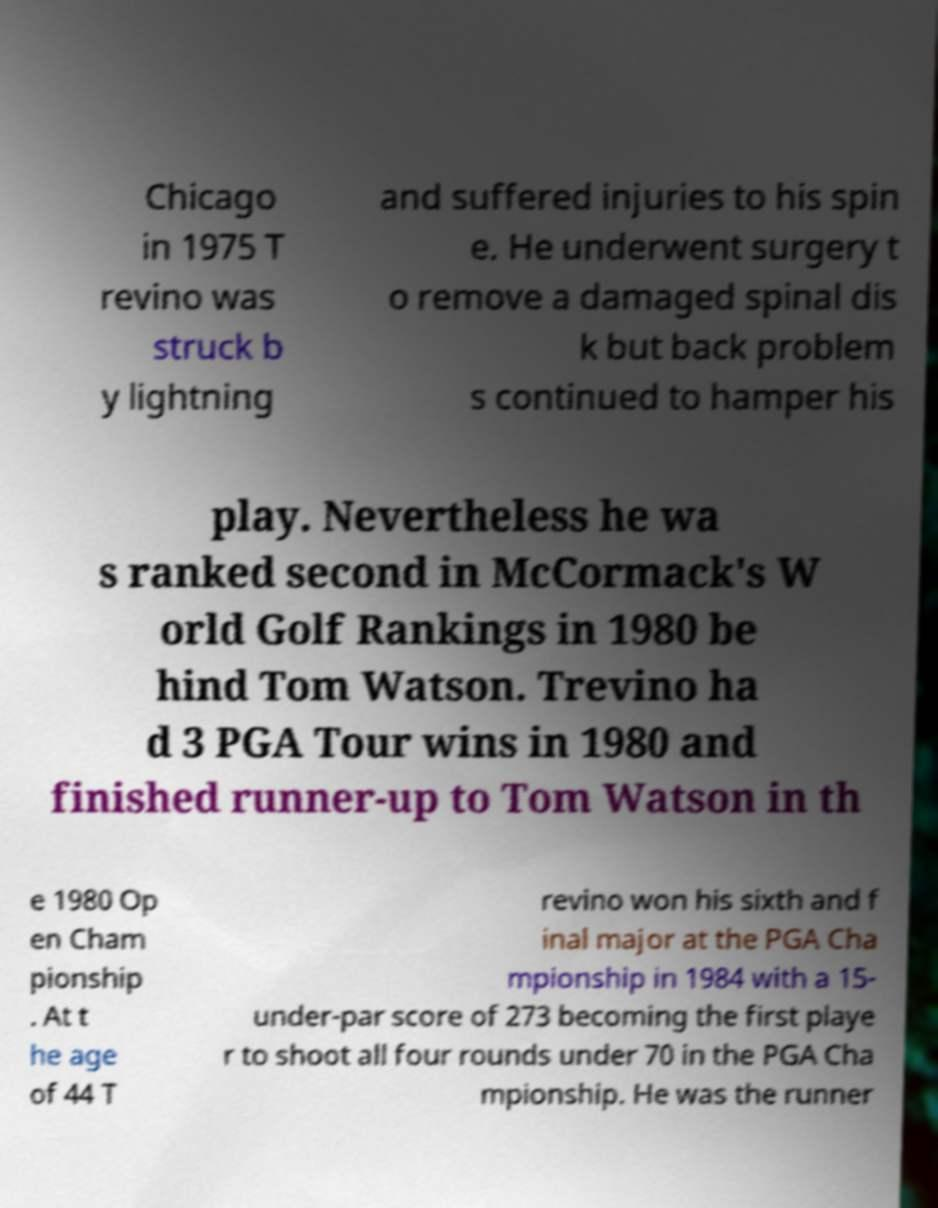Can you accurately transcribe the text from the provided image for me? Chicago in 1975 T revino was struck b y lightning and suffered injuries to his spin e. He underwent surgery t o remove a damaged spinal dis k but back problem s continued to hamper his play. Nevertheless he wa s ranked second in McCormack's W orld Golf Rankings in 1980 be hind Tom Watson. Trevino ha d 3 PGA Tour wins in 1980 and finished runner-up to Tom Watson in th e 1980 Op en Cham pionship . At t he age of 44 T revino won his sixth and f inal major at the PGA Cha mpionship in 1984 with a 15- under-par score of 273 becoming the first playe r to shoot all four rounds under 70 in the PGA Cha mpionship. He was the runner 